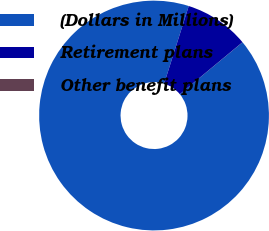<chart> <loc_0><loc_0><loc_500><loc_500><pie_chart><fcel>(Dollars in Millions)<fcel>Retirement plans<fcel>Other benefit plans<nl><fcel>90.89%<fcel>9.1%<fcel>0.01%<nl></chart> 